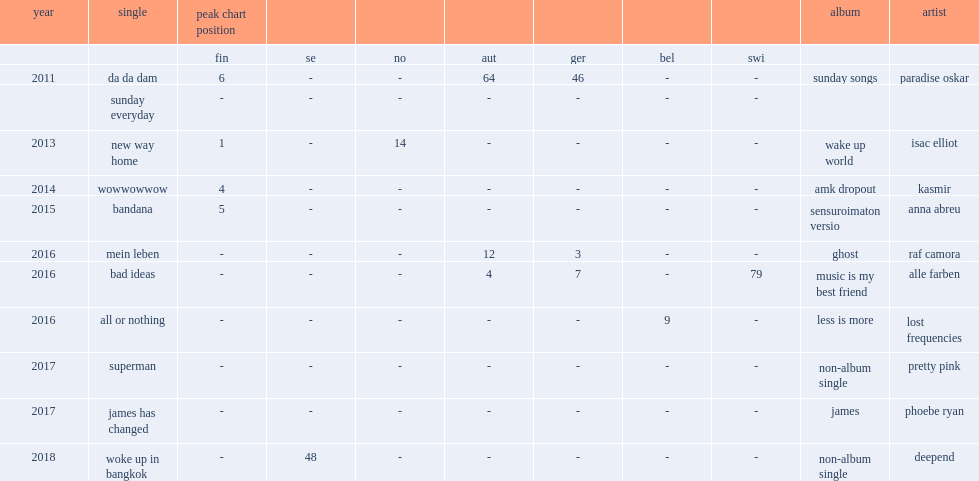When did paradise oskar release his debut album sunday songs? 2011.0. 